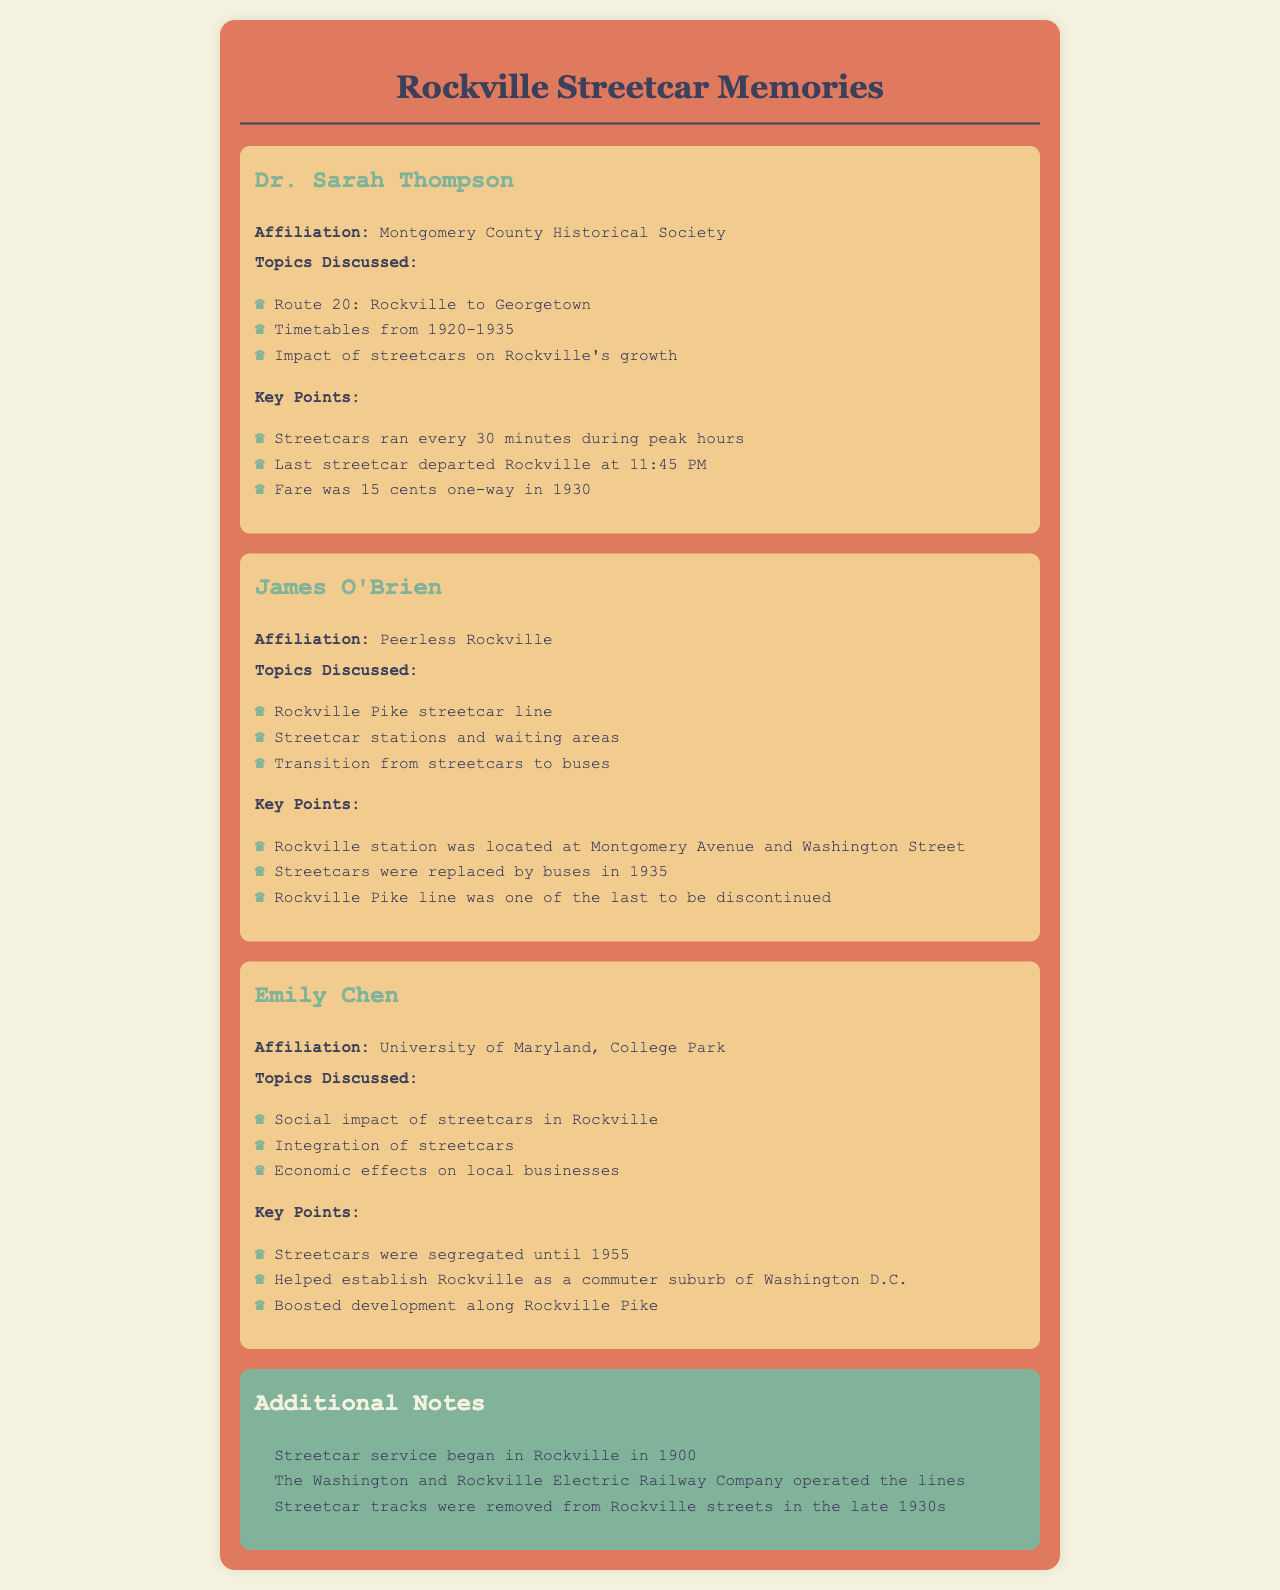What was the last departure time for streetcars from Rockville? The last streetcar left Rockville at 11:45 PM according to Dr. Sarah Thompson's notes.
Answer: 11:45 PM Who operated the streetcar service in Rockville? The document mentions the Washington and Rockville Electric Railway Company as the operator of the lines.
Answer: Washington and Rockville Electric Railway Company In which year did streetcar service begin in Rockville? The additional notes specify that streetcar service began in Rockville in 1900.
Answer: 1900 How many minutes did streetcars run during peak hours? According to Dr. Sarah Thompson, streetcars ran every 30 minutes during peak hours.
Answer: 30 minutes When were streetcars replaced by buses in Rockville? James O'Brien indicates that streetcars were replaced by buses in 1935.
Answer: 1935 What was the fare for a one-way trip in 1930? Dr. Sarah Thompson notes that the fare was 15 cents one-way in 1930.
Answer: 15 cents What impact did streetcars have on Rockville's development? Emily Chen discusses that streetcars helped establish Rockville as a commuter suburb of Washington D.C.
Answer: Commuter suburb Where was the Rockville streetcar station located? James O'Brien states that the Rockville station was at Montgomery Avenue and Washington Street.
Answer: Montgomery Avenue and Washington Street What year did the streetcar tracks get removed from Rockville streets? The additional notes mention that tracks were removed in the late 1930s.
Answer: Late 1930s 